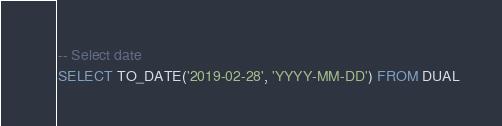<code> <loc_0><loc_0><loc_500><loc_500><_SQL_>-- Select date
SELECT TO_DATE('2019-02-28', 'YYYY-MM-DD') FROM DUAL</code> 